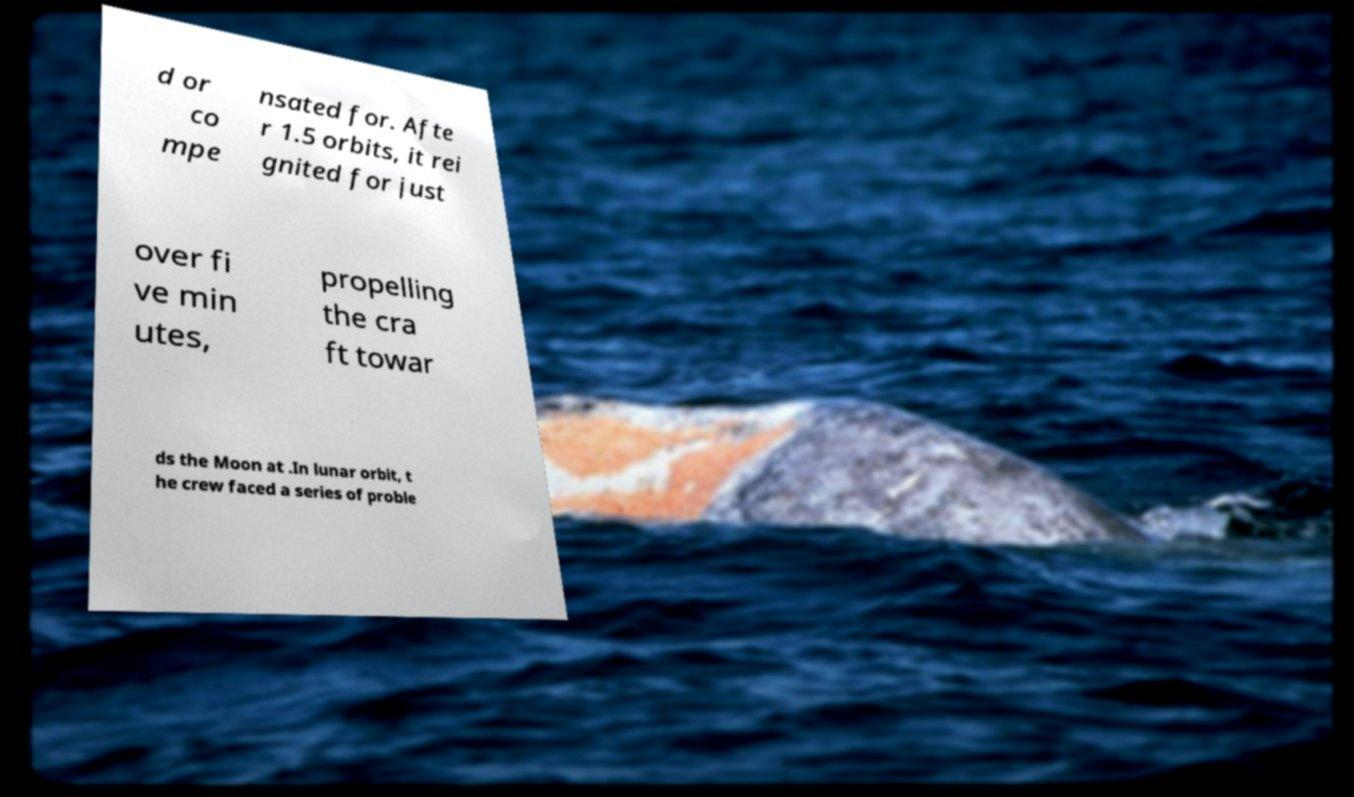Can you read and provide the text displayed in the image?This photo seems to have some interesting text. Can you extract and type it out for me? d or co mpe nsated for. Afte r 1.5 orbits, it rei gnited for just over fi ve min utes, propelling the cra ft towar ds the Moon at .In lunar orbit, t he crew faced a series of proble 